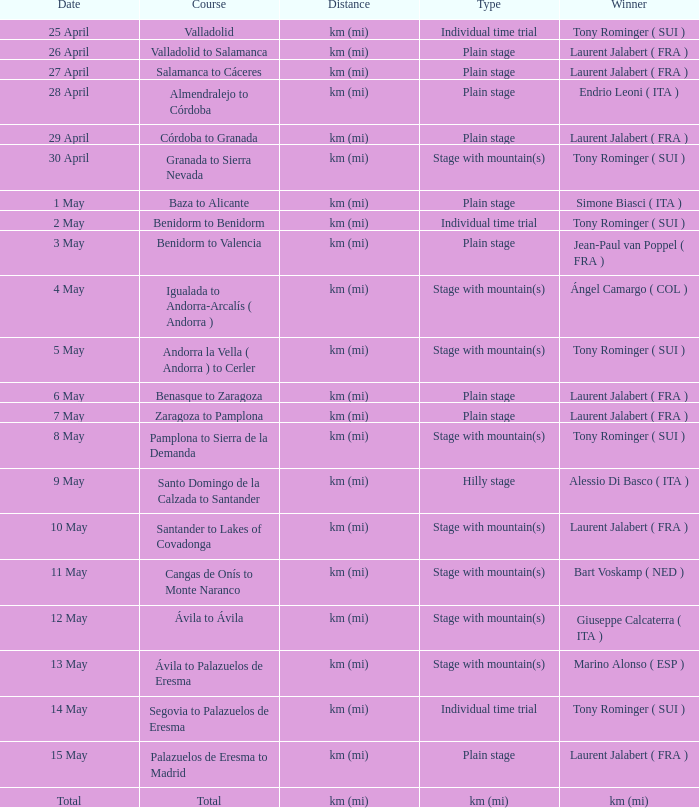Parse the table in full. {'header': ['Date', 'Course', 'Distance', 'Type', 'Winner'], 'rows': [['25 April', 'Valladolid', 'km (mi)', 'Individual time trial', 'Tony Rominger ( SUI )'], ['26 April', 'Valladolid to Salamanca', 'km (mi)', 'Plain stage', 'Laurent Jalabert ( FRA )'], ['27 April', 'Salamanca to Cáceres', 'km (mi)', 'Plain stage', 'Laurent Jalabert ( FRA )'], ['28 April', 'Almendralejo to Córdoba', 'km (mi)', 'Plain stage', 'Endrio Leoni ( ITA )'], ['29 April', 'Córdoba to Granada', 'km (mi)', 'Plain stage', 'Laurent Jalabert ( FRA )'], ['30 April', 'Granada to Sierra Nevada', 'km (mi)', 'Stage with mountain(s)', 'Tony Rominger ( SUI )'], ['1 May', 'Baza to Alicante', 'km (mi)', 'Plain stage', 'Simone Biasci ( ITA )'], ['2 May', 'Benidorm to Benidorm', 'km (mi)', 'Individual time trial', 'Tony Rominger ( SUI )'], ['3 May', 'Benidorm to Valencia', 'km (mi)', 'Plain stage', 'Jean-Paul van Poppel ( FRA )'], ['4 May', 'Igualada to Andorra-Arcalís ( Andorra )', 'km (mi)', 'Stage with mountain(s)', 'Ángel Camargo ( COL )'], ['5 May', 'Andorra la Vella ( Andorra ) to Cerler', 'km (mi)', 'Stage with mountain(s)', 'Tony Rominger ( SUI )'], ['6 May', 'Benasque to Zaragoza', 'km (mi)', 'Plain stage', 'Laurent Jalabert ( FRA )'], ['7 May', 'Zaragoza to Pamplona', 'km (mi)', 'Plain stage', 'Laurent Jalabert ( FRA )'], ['8 May', 'Pamplona to Sierra de la Demanda', 'km (mi)', 'Stage with mountain(s)', 'Tony Rominger ( SUI )'], ['9 May', 'Santo Domingo de la Calzada to Santander', 'km (mi)', 'Hilly stage', 'Alessio Di Basco ( ITA )'], ['10 May', 'Santander to Lakes of Covadonga', 'km (mi)', 'Stage with mountain(s)', 'Laurent Jalabert ( FRA )'], ['11 May', 'Cangas de Onís to Monte Naranco', 'km (mi)', 'Stage with mountain(s)', 'Bart Voskamp ( NED )'], ['12 May', 'Ávila to Ávila', 'km (mi)', 'Stage with mountain(s)', 'Giuseppe Calcaterra ( ITA )'], ['13 May', 'Ávila to Palazuelos de Eresma', 'km (mi)', 'Stage with mountain(s)', 'Marino Alonso ( ESP )'], ['14 May', 'Segovia to Palazuelos de Eresma', 'km (mi)', 'Individual time trial', 'Tony Rominger ( SUI )'], ['15 May', 'Palazuelos de Eresma to Madrid', 'km (mi)', 'Plain stage', 'Laurent Jalabert ( FRA )'], ['Total', 'Total', 'km (mi)', 'km (mi)', 'km (mi)']]} What was the day featuring a victor of km (mi)? Total. 